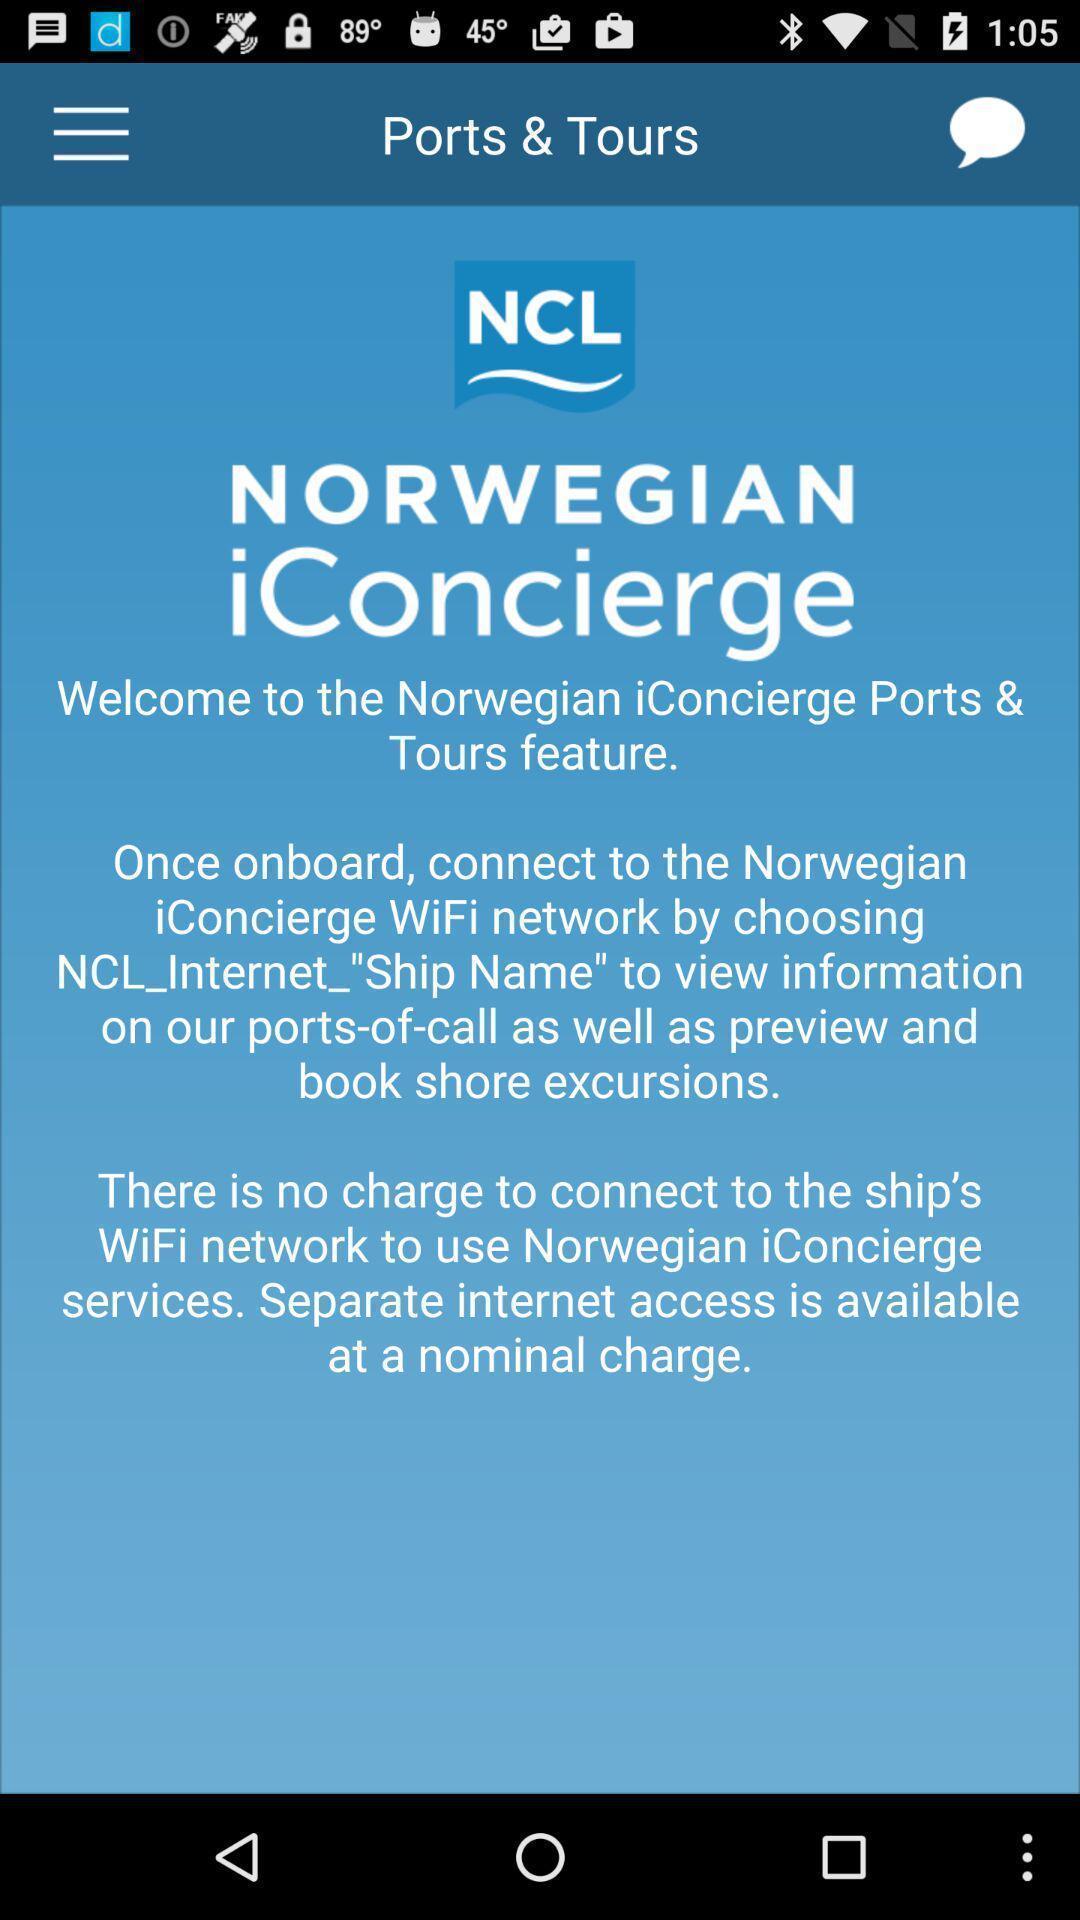What is the overall content of this screenshot? Welcome page of social app. 